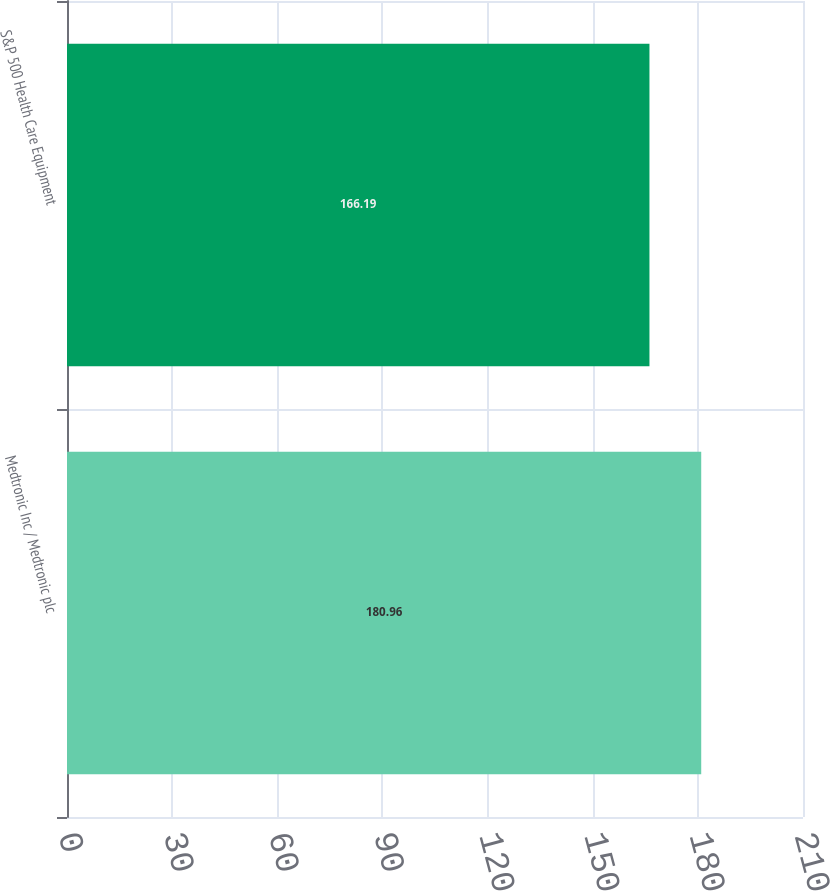Convert chart. <chart><loc_0><loc_0><loc_500><loc_500><bar_chart><fcel>Medtronic Inc / Medtronic plc<fcel>S&P 500 Health Care Equipment<nl><fcel>180.96<fcel>166.19<nl></chart> 